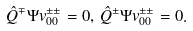<formula> <loc_0><loc_0><loc_500><loc_500>\hat { Q } ^ { \mp } \Psi v ^ { \pm \pm } _ { 0 0 } = 0 , \, \hat { Q } ^ { \pm } \Psi v ^ { \pm \pm } _ { 0 0 } = 0 .</formula> 